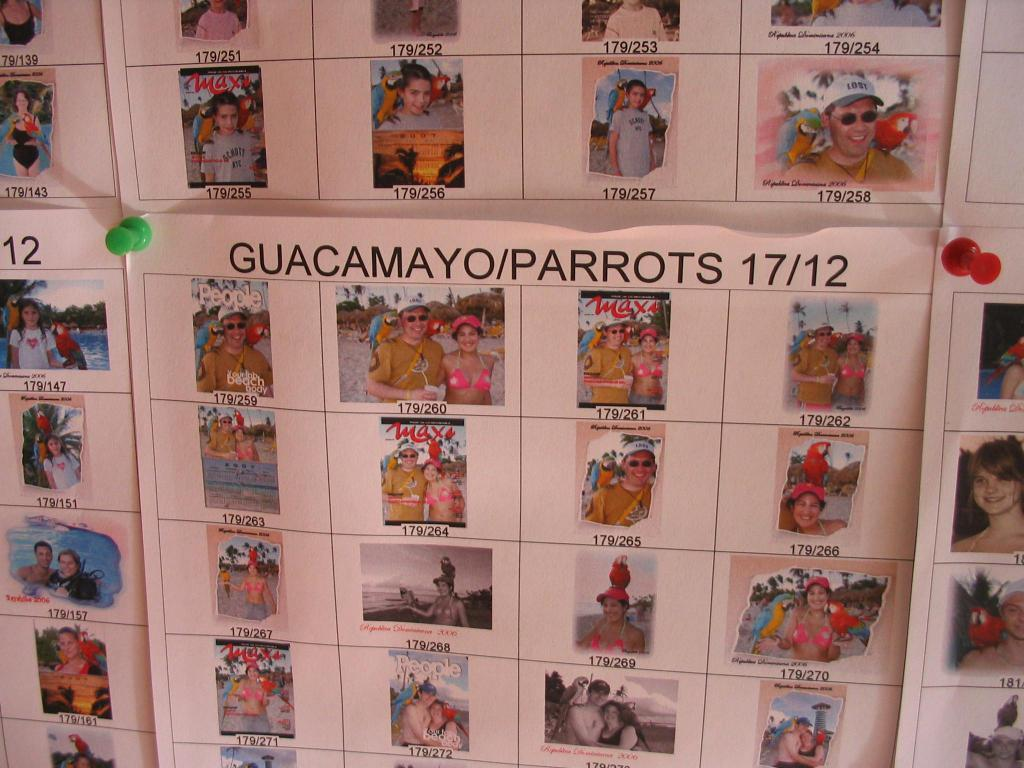What is present on the papers in the image? The papers have pictures on them. Can you describe the content of the pictures on the papers? Unfortunately, the specific content of the pictures cannot be determined from the provided facts. What type of leaf is depicted in the mountain scene on the silver paper? There is no leaf, mountain, or silver paper present in the image. 